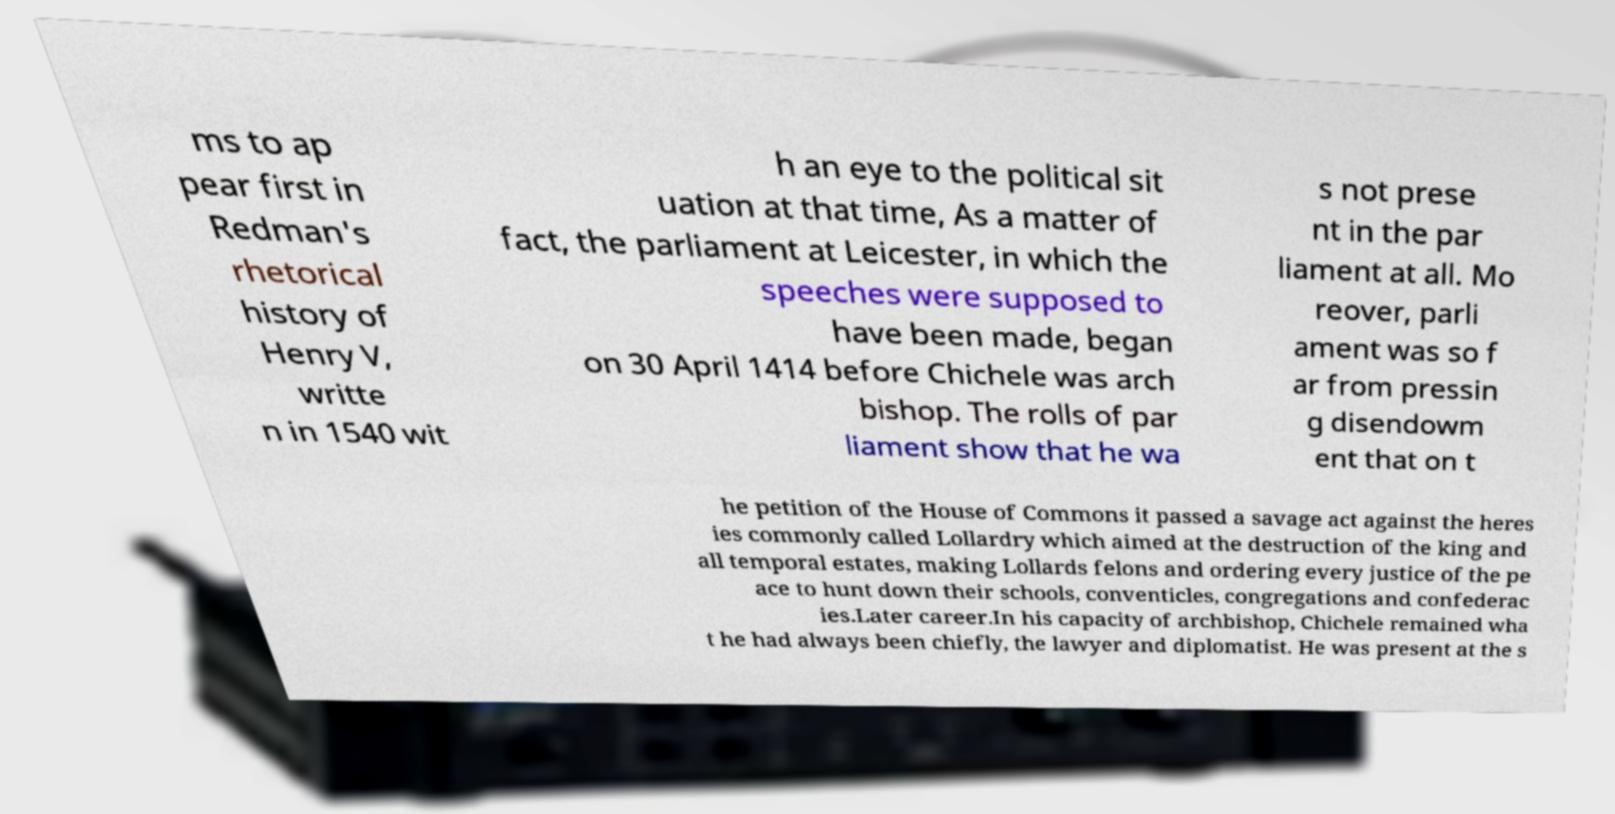Please read and relay the text visible in this image. What does it say? ms to ap pear first in Redman's rhetorical history of Henry V, writte n in 1540 wit h an eye to the political sit uation at that time, As a matter of fact, the parliament at Leicester, in which the speeches were supposed to have been made, began on 30 April 1414 before Chichele was arch bishop. The rolls of par liament show that he wa s not prese nt in the par liament at all. Mo reover, parli ament was so f ar from pressin g disendowm ent that on t he petition of the House of Commons it passed a savage act against the heres ies commonly called Lollardry which aimed at the destruction of the king and all temporal estates, making Lollards felons and ordering every justice of the pe ace to hunt down their schools, conventicles, congregations and confederac ies.Later career.In his capacity of archbishop, Chichele remained wha t he had always been chiefly, the lawyer and diplomatist. He was present at the s 